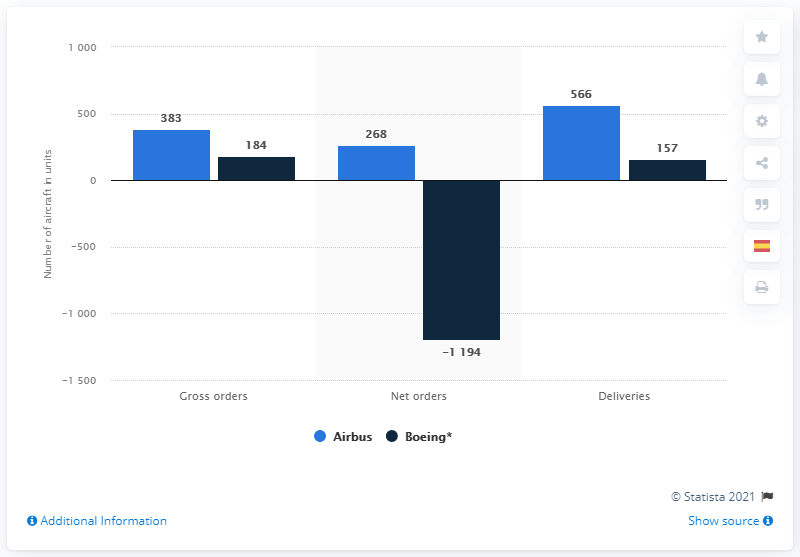Outline some significant characteristics in this image. In 2020, Boeing delivered a total of 157 aircraft, demonstrating its continued commitment to excellence in the aviation industry. In 2020, Airbus reported a total of 566 aircraft deliveries. 